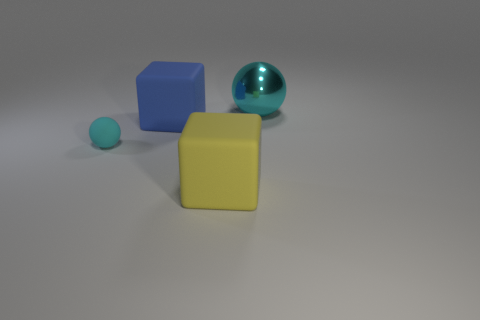Is the number of tiny cyan rubber things that are behind the small object greater than the number of matte objects?
Make the answer very short. No. Is there a big cyan block?
Your answer should be very brief. No. How many yellow matte objects have the same size as the blue thing?
Your response must be concise. 1. Is the number of large rubber blocks behind the metallic thing greater than the number of tiny objects right of the blue cube?
Provide a succinct answer. No. There is a blue cube that is the same size as the metallic sphere; what material is it?
Keep it short and to the point. Rubber. The small object is what shape?
Your response must be concise. Sphere. How many red objects are tiny metallic cylinders or large balls?
Keep it short and to the point. 0. The yellow cube that is the same material as the small cyan sphere is what size?
Give a very brief answer. Large. Is the big yellow block that is in front of the big cyan metal thing made of the same material as the cyan thing that is left of the big cyan shiny thing?
Your response must be concise. Yes. What number of cubes are either blue matte things or big yellow rubber things?
Make the answer very short. 2. 